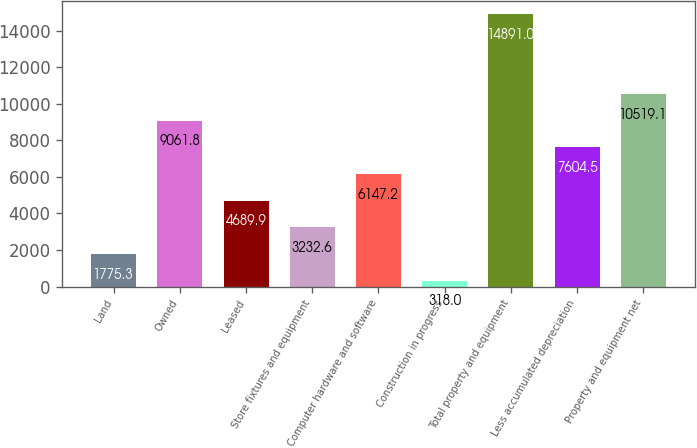Convert chart. <chart><loc_0><loc_0><loc_500><loc_500><bar_chart><fcel>Land<fcel>Owned<fcel>Leased<fcel>Store fixtures and equipment<fcel>Computer hardware and software<fcel>Construction in progress<fcel>Total property and equipment<fcel>Less accumulated depreciation<fcel>Property and equipment net<nl><fcel>1775.3<fcel>9061.8<fcel>4689.9<fcel>3232.6<fcel>6147.2<fcel>318<fcel>14891<fcel>7604.5<fcel>10519.1<nl></chart> 